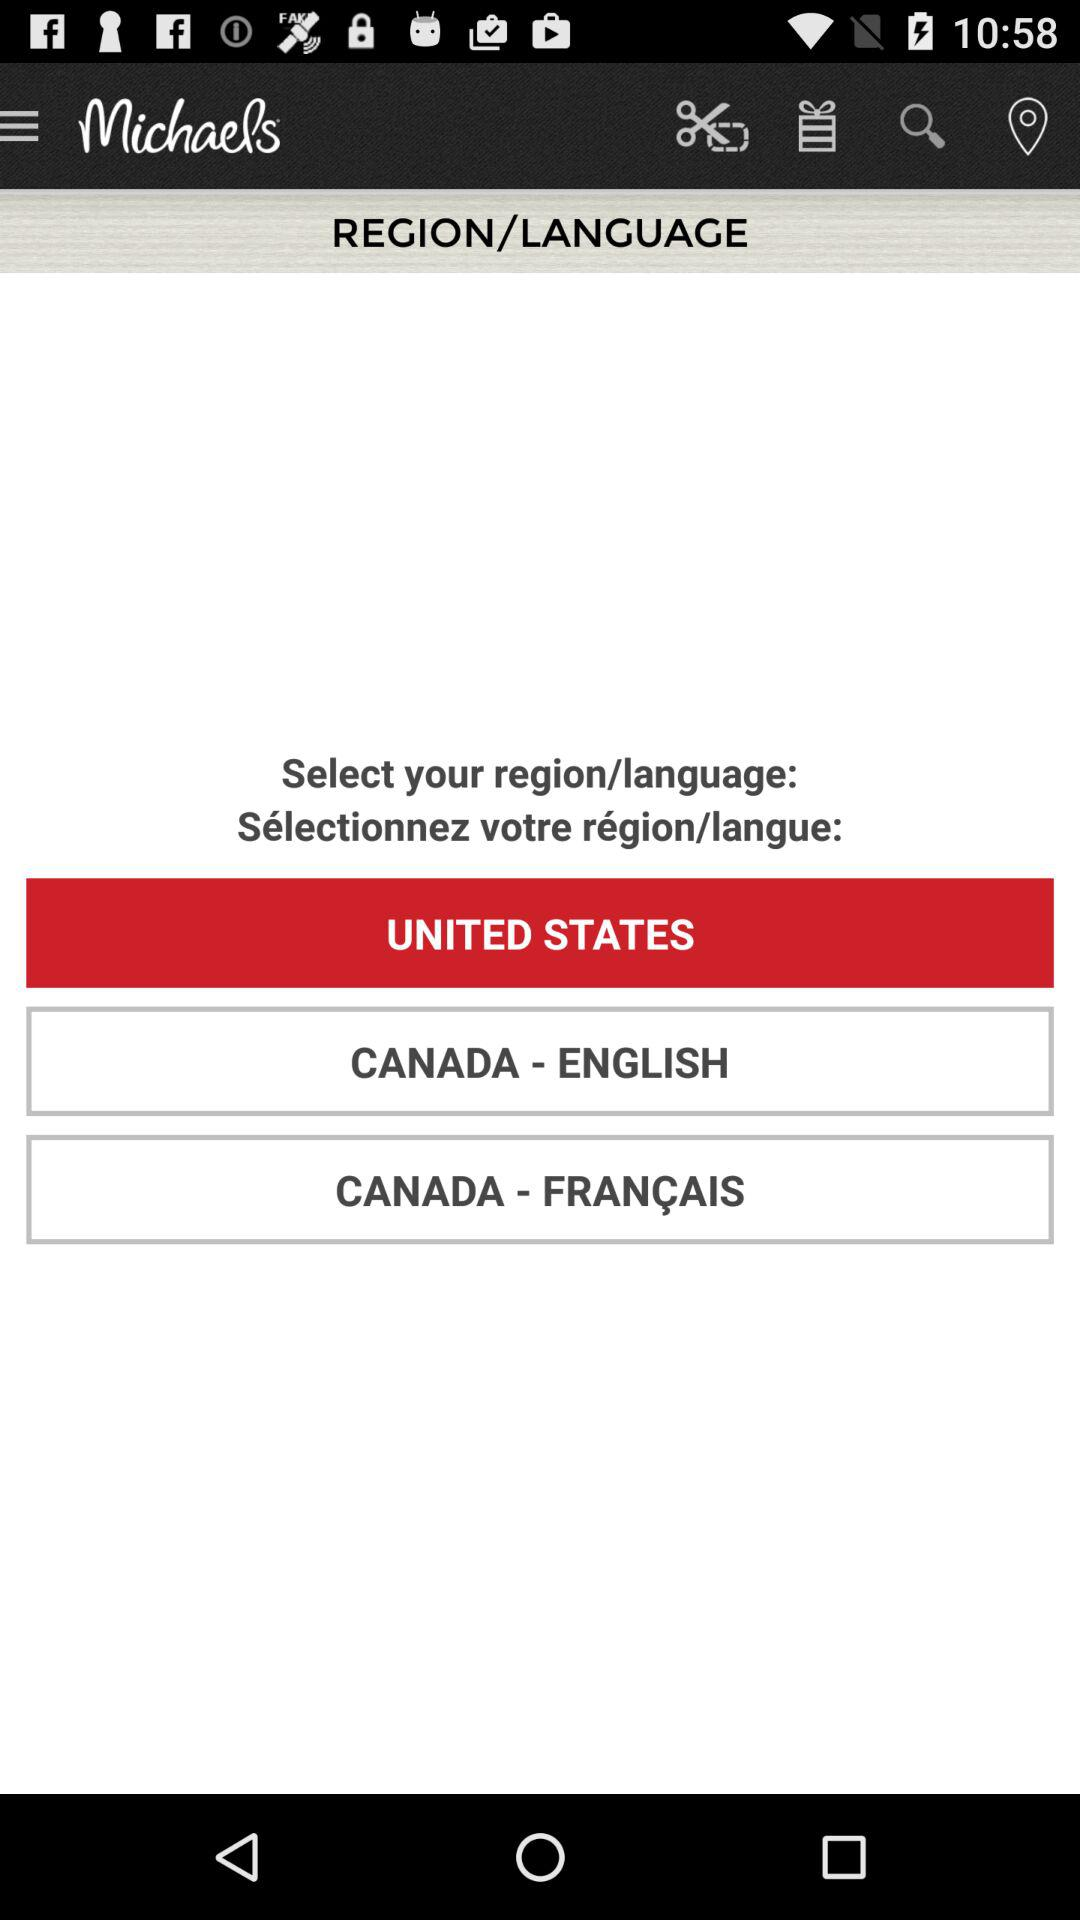For which item is the user searching?
When the provided information is insufficient, respond with <no answer>. <no answer> 